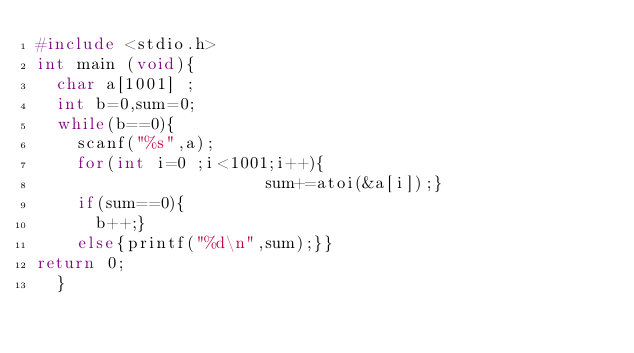Convert code to text. <code><loc_0><loc_0><loc_500><loc_500><_C_>#include <stdio.h>
int main (void){
	char a[1001] ;
	int b=0,sum=0;
	while(b==0){
		scanf("%s",a);
		for(int i=0 ;i<1001;i++){
                       sum+=atoi(&a[i]);}
		if(sum==0){
			b++;}
		else{printf("%d\n",sum);}}
return 0;
	}</code> 